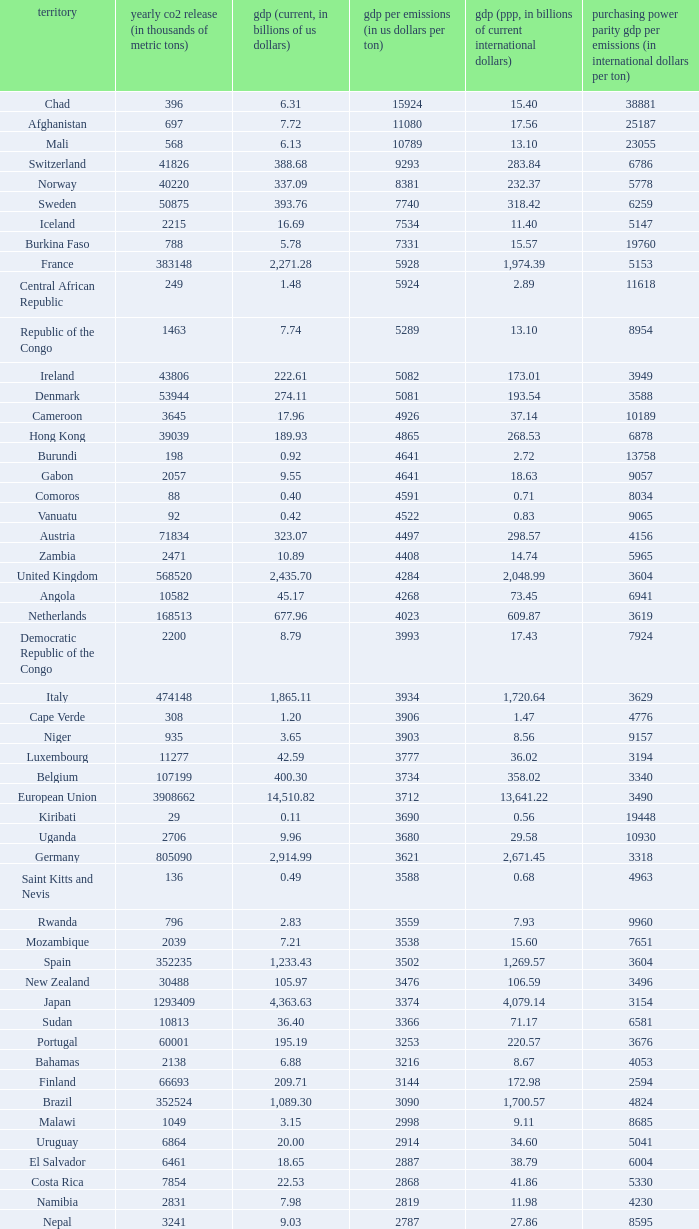When the gdp (ppp, in billions of current international dollars) is 7.93, what is the maximum ppp gdp per emissions (in international dollars per ton)? 9960.0. 